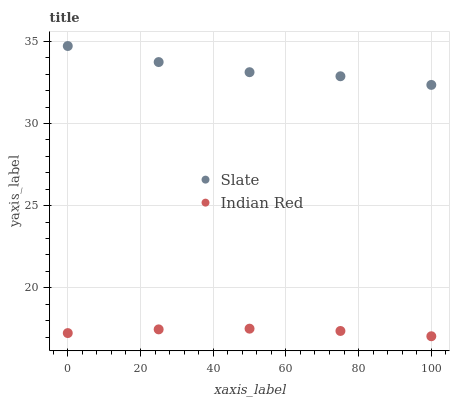Does Indian Red have the minimum area under the curve?
Answer yes or no. Yes. Does Slate have the maximum area under the curve?
Answer yes or no. Yes. Does Indian Red have the maximum area under the curve?
Answer yes or no. No. Is Indian Red the smoothest?
Answer yes or no. Yes. Is Slate the roughest?
Answer yes or no. Yes. Is Indian Red the roughest?
Answer yes or no. No. Does Indian Red have the lowest value?
Answer yes or no. Yes. Does Slate have the highest value?
Answer yes or no. Yes. Does Indian Red have the highest value?
Answer yes or no. No. Is Indian Red less than Slate?
Answer yes or no. Yes. Is Slate greater than Indian Red?
Answer yes or no. Yes. Does Indian Red intersect Slate?
Answer yes or no. No. 